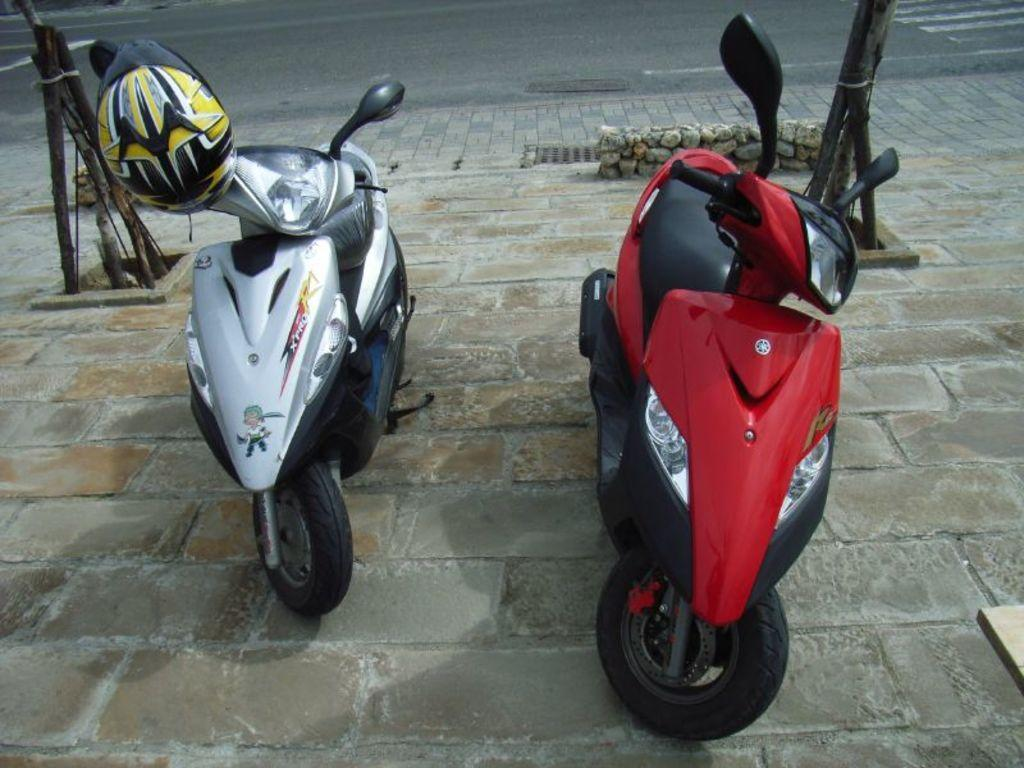How many scooters are in the image? There are two scooters in the image. Where are the scooters located? The scooters are on the side of the road. What safety equipment is visible on one of the scooters? There is a helmet on the left side scooter. What can be seen behind the scooters? There is a road visible behind the scooters. What month is it in the image? The month cannot be determined from the image, as there is no information about the time of year. 